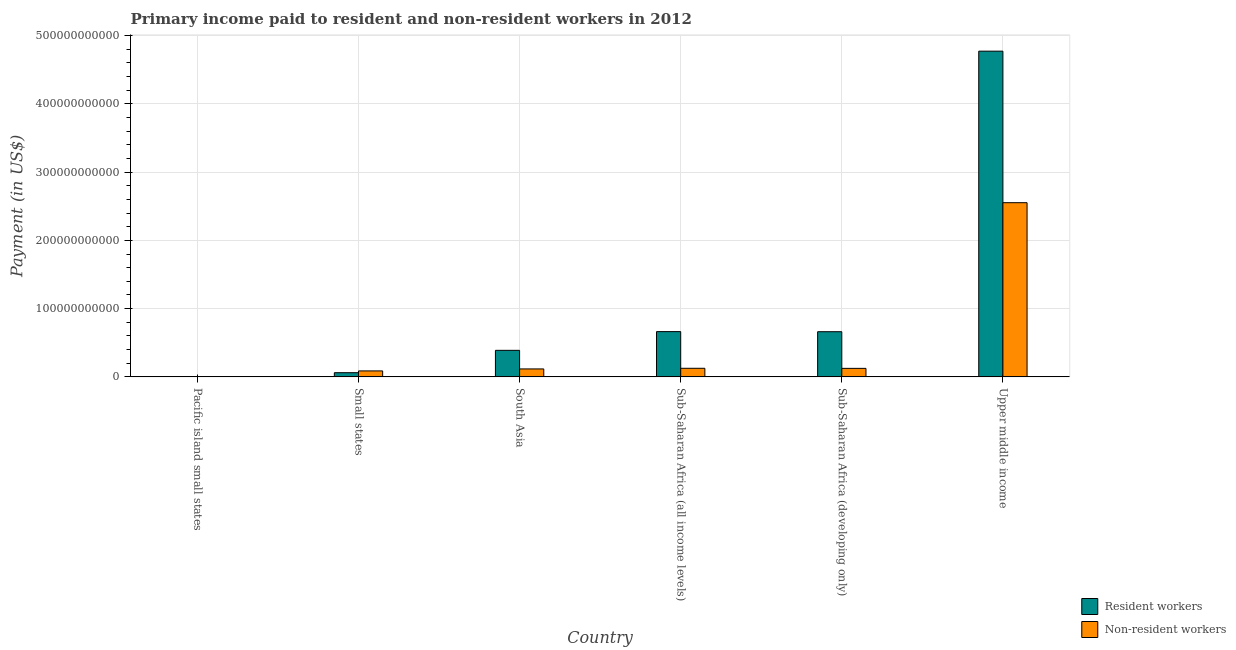How many groups of bars are there?
Your answer should be very brief. 6. Are the number of bars on each tick of the X-axis equal?
Offer a very short reply. Yes. How many bars are there on the 2nd tick from the left?
Ensure brevity in your answer.  2. What is the label of the 1st group of bars from the left?
Give a very brief answer. Pacific island small states. What is the payment made to non-resident workers in Small states?
Give a very brief answer. 8.73e+09. Across all countries, what is the maximum payment made to resident workers?
Give a very brief answer. 4.77e+11. Across all countries, what is the minimum payment made to non-resident workers?
Offer a terse response. 3.71e+08. In which country was the payment made to resident workers maximum?
Offer a terse response. Upper middle income. In which country was the payment made to resident workers minimum?
Provide a succinct answer. Pacific island small states. What is the total payment made to non-resident workers in the graph?
Give a very brief answer. 3.01e+11. What is the difference between the payment made to non-resident workers in Pacific island small states and that in Upper middle income?
Keep it short and to the point. -2.55e+11. What is the difference between the payment made to resident workers in Pacific island small states and the payment made to non-resident workers in Sub-Saharan Africa (developing only)?
Your response must be concise. -1.19e+1. What is the average payment made to non-resident workers per country?
Offer a very short reply. 5.02e+1. What is the difference between the payment made to non-resident workers and payment made to resident workers in Sub-Saharan Africa (all income levels)?
Offer a terse response. -5.37e+1. What is the ratio of the payment made to resident workers in Pacific island small states to that in Small states?
Offer a very short reply. 0.09. What is the difference between the highest and the second highest payment made to resident workers?
Make the answer very short. 4.11e+11. What is the difference between the highest and the lowest payment made to resident workers?
Ensure brevity in your answer.  4.77e+11. What does the 2nd bar from the left in Sub-Saharan Africa (developing only) represents?
Make the answer very short. Non-resident workers. What does the 1st bar from the right in Small states represents?
Make the answer very short. Non-resident workers. Are all the bars in the graph horizontal?
Offer a very short reply. No. How many countries are there in the graph?
Your answer should be compact. 6. What is the difference between two consecutive major ticks on the Y-axis?
Offer a terse response. 1.00e+11. Are the values on the major ticks of Y-axis written in scientific E-notation?
Ensure brevity in your answer.  No. Does the graph contain any zero values?
Offer a very short reply. No. Where does the legend appear in the graph?
Your response must be concise. Bottom right. How are the legend labels stacked?
Give a very brief answer. Vertical. What is the title of the graph?
Provide a succinct answer. Primary income paid to resident and non-resident workers in 2012. What is the label or title of the Y-axis?
Make the answer very short. Payment (in US$). What is the Payment (in US$) of Resident workers in Pacific island small states?
Your answer should be compact. 5.35e+08. What is the Payment (in US$) in Non-resident workers in Pacific island small states?
Provide a short and direct response. 3.71e+08. What is the Payment (in US$) in Resident workers in Small states?
Provide a succinct answer. 6.12e+09. What is the Payment (in US$) of Non-resident workers in Small states?
Provide a short and direct response. 8.73e+09. What is the Payment (in US$) in Resident workers in South Asia?
Provide a succinct answer. 3.89e+1. What is the Payment (in US$) of Non-resident workers in South Asia?
Your response must be concise. 1.16e+1. What is the Payment (in US$) of Resident workers in Sub-Saharan Africa (all income levels)?
Offer a terse response. 6.63e+1. What is the Payment (in US$) of Non-resident workers in Sub-Saharan Africa (all income levels)?
Provide a succinct answer. 1.26e+1. What is the Payment (in US$) of Resident workers in Sub-Saharan Africa (developing only)?
Provide a short and direct response. 6.62e+1. What is the Payment (in US$) in Non-resident workers in Sub-Saharan Africa (developing only)?
Provide a short and direct response. 1.25e+1. What is the Payment (in US$) of Resident workers in Upper middle income?
Keep it short and to the point. 4.77e+11. What is the Payment (in US$) of Non-resident workers in Upper middle income?
Offer a terse response. 2.55e+11. Across all countries, what is the maximum Payment (in US$) of Resident workers?
Provide a succinct answer. 4.77e+11. Across all countries, what is the maximum Payment (in US$) in Non-resident workers?
Offer a very short reply. 2.55e+11. Across all countries, what is the minimum Payment (in US$) in Resident workers?
Your response must be concise. 5.35e+08. Across all countries, what is the minimum Payment (in US$) of Non-resident workers?
Give a very brief answer. 3.71e+08. What is the total Payment (in US$) of Resident workers in the graph?
Your answer should be very brief. 6.55e+11. What is the total Payment (in US$) of Non-resident workers in the graph?
Make the answer very short. 3.01e+11. What is the difference between the Payment (in US$) in Resident workers in Pacific island small states and that in Small states?
Provide a succinct answer. -5.59e+09. What is the difference between the Payment (in US$) in Non-resident workers in Pacific island small states and that in Small states?
Your answer should be compact. -8.36e+09. What is the difference between the Payment (in US$) in Resident workers in Pacific island small states and that in South Asia?
Give a very brief answer. -3.84e+1. What is the difference between the Payment (in US$) in Non-resident workers in Pacific island small states and that in South Asia?
Your response must be concise. -1.13e+1. What is the difference between the Payment (in US$) in Resident workers in Pacific island small states and that in Sub-Saharan Africa (all income levels)?
Provide a succinct answer. -6.58e+1. What is the difference between the Payment (in US$) of Non-resident workers in Pacific island small states and that in Sub-Saharan Africa (all income levels)?
Ensure brevity in your answer.  -1.22e+1. What is the difference between the Payment (in US$) of Resident workers in Pacific island small states and that in Sub-Saharan Africa (developing only)?
Give a very brief answer. -6.56e+1. What is the difference between the Payment (in US$) of Non-resident workers in Pacific island small states and that in Sub-Saharan Africa (developing only)?
Give a very brief answer. -1.21e+1. What is the difference between the Payment (in US$) in Resident workers in Pacific island small states and that in Upper middle income?
Ensure brevity in your answer.  -4.77e+11. What is the difference between the Payment (in US$) in Non-resident workers in Pacific island small states and that in Upper middle income?
Your response must be concise. -2.55e+11. What is the difference between the Payment (in US$) of Resident workers in Small states and that in South Asia?
Your answer should be compact. -3.28e+1. What is the difference between the Payment (in US$) in Non-resident workers in Small states and that in South Asia?
Offer a terse response. -2.91e+09. What is the difference between the Payment (in US$) of Resident workers in Small states and that in Sub-Saharan Africa (all income levels)?
Your response must be concise. -6.02e+1. What is the difference between the Payment (in US$) in Non-resident workers in Small states and that in Sub-Saharan Africa (all income levels)?
Offer a very short reply. -3.85e+09. What is the difference between the Payment (in US$) in Resident workers in Small states and that in Sub-Saharan Africa (developing only)?
Your response must be concise. -6.01e+1. What is the difference between the Payment (in US$) in Non-resident workers in Small states and that in Sub-Saharan Africa (developing only)?
Your answer should be very brief. -3.73e+09. What is the difference between the Payment (in US$) of Resident workers in Small states and that in Upper middle income?
Make the answer very short. -4.71e+11. What is the difference between the Payment (in US$) of Non-resident workers in Small states and that in Upper middle income?
Keep it short and to the point. -2.46e+11. What is the difference between the Payment (in US$) in Resident workers in South Asia and that in Sub-Saharan Africa (all income levels)?
Ensure brevity in your answer.  -2.74e+1. What is the difference between the Payment (in US$) of Non-resident workers in South Asia and that in Sub-Saharan Africa (all income levels)?
Make the answer very short. -9.39e+08. What is the difference between the Payment (in US$) of Resident workers in South Asia and that in Sub-Saharan Africa (developing only)?
Your response must be concise. -2.73e+1. What is the difference between the Payment (in US$) in Non-resident workers in South Asia and that in Sub-Saharan Africa (developing only)?
Make the answer very short. -8.21e+08. What is the difference between the Payment (in US$) in Resident workers in South Asia and that in Upper middle income?
Make the answer very short. -4.38e+11. What is the difference between the Payment (in US$) of Non-resident workers in South Asia and that in Upper middle income?
Your answer should be compact. -2.44e+11. What is the difference between the Payment (in US$) of Resident workers in Sub-Saharan Africa (all income levels) and that in Sub-Saharan Africa (developing only)?
Give a very brief answer. 1.24e+08. What is the difference between the Payment (in US$) of Non-resident workers in Sub-Saharan Africa (all income levels) and that in Sub-Saharan Africa (developing only)?
Offer a terse response. 1.17e+08. What is the difference between the Payment (in US$) of Resident workers in Sub-Saharan Africa (all income levels) and that in Upper middle income?
Your response must be concise. -4.11e+11. What is the difference between the Payment (in US$) in Non-resident workers in Sub-Saharan Africa (all income levels) and that in Upper middle income?
Provide a short and direct response. -2.43e+11. What is the difference between the Payment (in US$) in Resident workers in Sub-Saharan Africa (developing only) and that in Upper middle income?
Offer a terse response. -4.11e+11. What is the difference between the Payment (in US$) of Non-resident workers in Sub-Saharan Africa (developing only) and that in Upper middle income?
Keep it short and to the point. -2.43e+11. What is the difference between the Payment (in US$) of Resident workers in Pacific island small states and the Payment (in US$) of Non-resident workers in Small states?
Your answer should be compact. -8.20e+09. What is the difference between the Payment (in US$) of Resident workers in Pacific island small states and the Payment (in US$) of Non-resident workers in South Asia?
Your response must be concise. -1.11e+1. What is the difference between the Payment (in US$) of Resident workers in Pacific island small states and the Payment (in US$) of Non-resident workers in Sub-Saharan Africa (all income levels)?
Your answer should be very brief. -1.20e+1. What is the difference between the Payment (in US$) of Resident workers in Pacific island small states and the Payment (in US$) of Non-resident workers in Sub-Saharan Africa (developing only)?
Make the answer very short. -1.19e+1. What is the difference between the Payment (in US$) of Resident workers in Pacific island small states and the Payment (in US$) of Non-resident workers in Upper middle income?
Your answer should be compact. -2.55e+11. What is the difference between the Payment (in US$) in Resident workers in Small states and the Payment (in US$) in Non-resident workers in South Asia?
Offer a very short reply. -5.52e+09. What is the difference between the Payment (in US$) in Resident workers in Small states and the Payment (in US$) in Non-resident workers in Sub-Saharan Africa (all income levels)?
Your response must be concise. -6.46e+09. What is the difference between the Payment (in US$) in Resident workers in Small states and the Payment (in US$) in Non-resident workers in Sub-Saharan Africa (developing only)?
Provide a succinct answer. -6.34e+09. What is the difference between the Payment (in US$) in Resident workers in Small states and the Payment (in US$) in Non-resident workers in Upper middle income?
Give a very brief answer. -2.49e+11. What is the difference between the Payment (in US$) of Resident workers in South Asia and the Payment (in US$) of Non-resident workers in Sub-Saharan Africa (all income levels)?
Your response must be concise. 2.63e+1. What is the difference between the Payment (in US$) in Resident workers in South Asia and the Payment (in US$) in Non-resident workers in Sub-Saharan Africa (developing only)?
Your answer should be very brief. 2.64e+1. What is the difference between the Payment (in US$) of Resident workers in South Asia and the Payment (in US$) of Non-resident workers in Upper middle income?
Make the answer very short. -2.16e+11. What is the difference between the Payment (in US$) in Resident workers in Sub-Saharan Africa (all income levels) and the Payment (in US$) in Non-resident workers in Sub-Saharan Africa (developing only)?
Your response must be concise. 5.38e+1. What is the difference between the Payment (in US$) of Resident workers in Sub-Saharan Africa (all income levels) and the Payment (in US$) of Non-resident workers in Upper middle income?
Your answer should be very brief. -1.89e+11. What is the difference between the Payment (in US$) of Resident workers in Sub-Saharan Africa (developing only) and the Payment (in US$) of Non-resident workers in Upper middle income?
Keep it short and to the point. -1.89e+11. What is the average Payment (in US$) in Resident workers per country?
Your answer should be compact. 1.09e+11. What is the average Payment (in US$) in Non-resident workers per country?
Offer a terse response. 5.02e+1. What is the difference between the Payment (in US$) in Resident workers and Payment (in US$) in Non-resident workers in Pacific island small states?
Make the answer very short. 1.64e+08. What is the difference between the Payment (in US$) in Resident workers and Payment (in US$) in Non-resident workers in Small states?
Provide a succinct answer. -2.61e+09. What is the difference between the Payment (in US$) in Resident workers and Payment (in US$) in Non-resident workers in South Asia?
Offer a terse response. 2.73e+1. What is the difference between the Payment (in US$) of Resident workers and Payment (in US$) of Non-resident workers in Sub-Saharan Africa (all income levels)?
Keep it short and to the point. 5.37e+1. What is the difference between the Payment (in US$) of Resident workers and Payment (in US$) of Non-resident workers in Sub-Saharan Africa (developing only)?
Your response must be concise. 5.37e+1. What is the difference between the Payment (in US$) in Resident workers and Payment (in US$) in Non-resident workers in Upper middle income?
Offer a very short reply. 2.22e+11. What is the ratio of the Payment (in US$) in Resident workers in Pacific island small states to that in Small states?
Offer a terse response. 0.09. What is the ratio of the Payment (in US$) of Non-resident workers in Pacific island small states to that in Small states?
Ensure brevity in your answer.  0.04. What is the ratio of the Payment (in US$) of Resident workers in Pacific island small states to that in South Asia?
Your answer should be very brief. 0.01. What is the ratio of the Payment (in US$) of Non-resident workers in Pacific island small states to that in South Asia?
Your answer should be compact. 0.03. What is the ratio of the Payment (in US$) of Resident workers in Pacific island small states to that in Sub-Saharan Africa (all income levels)?
Keep it short and to the point. 0.01. What is the ratio of the Payment (in US$) of Non-resident workers in Pacific island small states to that in Sub-Saharan Africa (all income levels)?
Ensure brevity in your answer.  0.03. What is the ratio of the Payment (in US$) in Resident workers in Pacific island small states to that in Sub-Saharan Africa (developing only)?
Offer a very short reply. 0.01. What is the ratio of the Payment (in US$) in Non-resident workers in Pacific island small states to that in Sub-Saharan Africa (developing only)?
Your response must be concise. 0.03. What is the ratio of the Payment (in US$) in Resident workers in Pacific island small states to that in Upper middle income?
Give a very brief answer. 0. What is the ratio of the Payment (in US$) in Non-resident workers in Pacific island small states to that in Upper middle income?
Keep it short and to the point. 0. What is the ratio of the Payment (in US$) in Resident workers in Small states to that in South Asia?
Your response must be concise. 0.16. What is the ratio of the Payment (in US$) of Non-resident workers in Small states to that in South Asia?
Your answer should be very brief. 0.75. What is the ratio of the Payment (in US$) in Resident workers in Small states to that in Sub-Saharan Africa (all income levels)?
Offer a terse response. 0.09. What is the ratio of the Payment (in US$) in Non-resident workers in Small states to that in Sub-Saharan Africa (all income levels)?
Keep it short and to the point. 0.69. What is the ratio of the Payment (in US$) of Resident workers in Small states to that in Sub-Saharan Africa (developing only)?
Ensure brevity in your answer.  0.09. What is the ratio of the Payment (in US$) in Non-resident workers in Small states to that in Sub-Saharan Africa (developing only)?
Offer a terse response. 0.7. What is the ratio of the Payment (in US$) in Resident workers in Small states to that in Upper middle income?
Your answer should be compact. 0.01. What is the ratio of the Payment (in US$) in Non-resident workers in Small states to that in Upper middle income?
Provide a short and direct response. 0.03. What is the ratio of the Payment (in US$) of Resident workers in South Asia to that in Sub-Saharan Africa (all income levels)?
Offer a terse response. 0.59. What is the ratio of the Payment (in US$) in Non-resident workers in South Asia to that in Sub-Saharan Africa (all income levels)?
Make the answer very short. 0.93. What is the ratio of the Payment (in US$) of Resident workers in South Asia to that in Sub-Saharan Africa (developing only)?
Give a very brief answer. 0.59. What is the ratio of the Payment (in US$) in Non-resident workers in South Asia to that in Sub-Saharan Africa (developing only)?
Provide a short and direct response. 0.93. What is the ratio of the Payment (in US$) of Resident workers in South Asia to that in Upper middle income?
Your answer should be compact. 0.08. What is the ratio of the Payment (in US$) in Non-resident workers in South Asia to that in Upper middle income?
Your response must be concise. 0.05. What is the ratio of the Payment (in US$) in Non-resident workers in Sub-Saharan Africa (all income levels) to that in Sub-Saharan Africa (developing only)?
Offer a very short reply. 1.01. What is the ratio of the Payment (in US$) in Resident workers in Sub-Saharan Africa (all income levels) to that in Upper middle income?
Make the answer very short. 0.14. What is the ratio of the Payment (in US$) in Non-resident workers in Sub-Saharan Africa (all income levels) to that in Upper middle income?
Your answer should be compact. 0.05. What is the ratio of the Payment (in US$) of Resident workers in Sub-Saharan Africa (developing only) to that in Upper middle income?
Offer a terse response. 0.14. What is the ratio of the Payment (in US$) in Non-resident workers in Sub-Saharan Africa (developing only) to that in Upper middle income?
Your answer should be compact. 0.05. What is the difference between the highest and the second highest Payment (in US$) in Resident workers?
Provide a short and direct response. 4.11e+11. What is the difference between the highest and the second highest Payment (in US$) in Non-resident workers?
Ensure brevity in your answer.  2.43e+11. What is the difference between the highest and the lowest Payment (in US$) of Resident workers?
Provide a succinct answer. 4.77e+11. What is the difference between the highest and the lowest Payment (in US$) in Non-resident workers?
Keep it short and to the point. 2.55e+11. 